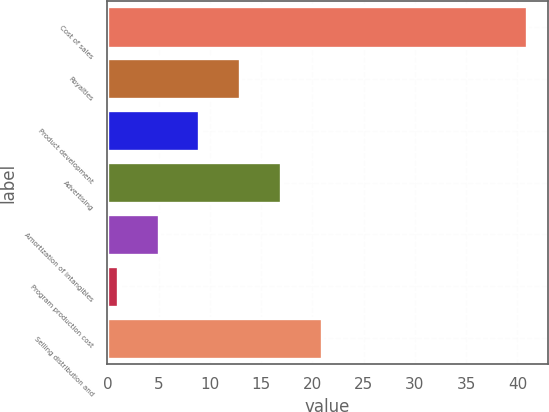Convert chart to OTSL. <chart><loc_0><loc_0><loc_500><loc_500><bar_chart><fcel>Cost of sales<fcel>Royalties<fcel>Product development<fcel>Advertising<fcel>Amortization of intangibles<fcel>Program production cost<fcel>Selling distribution and<nl><fcel>40.9<fcel>12.97<fcel>8.98<fcel>16.96<fcel>4.99<fcel>1<fcel>20.95<nl></chart> 